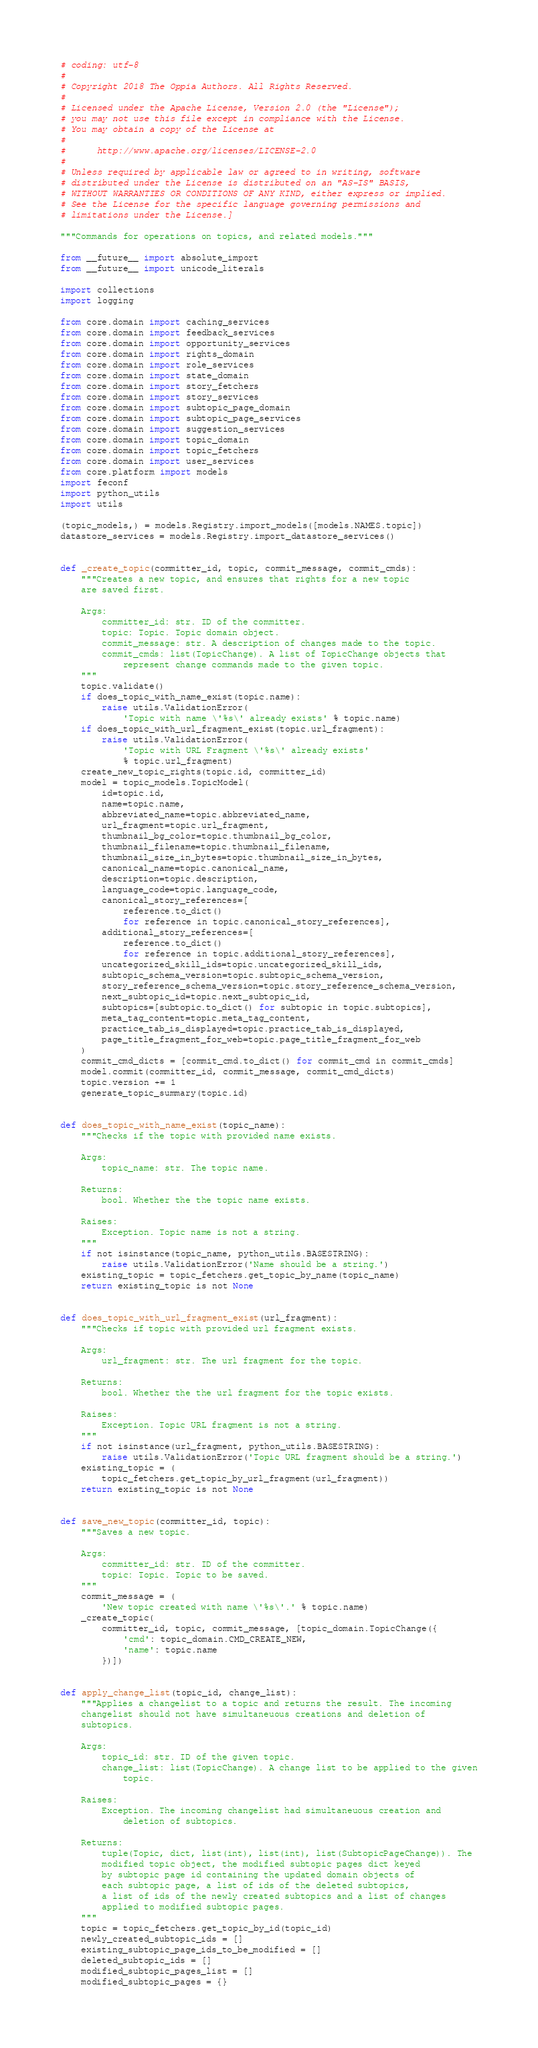<code> <loc_0><loc_0><loc_500><loc_500><_Python_># coding: utf-8
#
# Copyright 2018 The Oppia Authors. All Rights Reserved.
#
# Licensed under the Apache License, Version 2.0 (the "License");
# you may not use this file except in compliance with the License.
# You may obtain a copy of the License at
#
#      http://www.apache.org/licenses/LICENSE-2.0
#
# Unless required by applicable law or agreed to in writing, software
# distributed under the License is distributed on an "AS-IS" BASIS,
# WITHOUT WARRANTIES OR CONDITIONS OF ANY KIND, either express or implied.
# See the License for the specific language governing permissions and
# limitations under the License.]

"""Commands for operations on topics, and related models."""

from __future__ import absolute_import
from __future__ import unicode_literals

import collections
import logging

from core.domain import caching_services
from core.domain import feedback_services
from core.domain import opportunity_services
from core.domain import rights_domain
from core.domain import role_services
from core.domain import state_domain
from core.domain import story_fetchers
from core.domain import story_services
from core.domain import subtopic_page_domain
from core.domain import subtopic_page_services
from core.domain import suggestion_services
from core.domain import topic_domain
from core.domain import topic_fetchers
from core.domain import user_services
from core.platform import models
import feconf
import python_utils
import utils

(topic_models,) = models.Registry.import_models([models.NAMES.topic])
datastore_services = models.Registry.import_datastore_services()


def _create_topic(committer_id, topic, commit_message, commit_cmds):
    """Creates a new topic, and ensures that rights for a new topic
    are saved first.

    Args:
        committer_id: str. ID of the committer.
        topic: Topic. Topic domain object.
        commit_message: str. A description of changes made to the topic.
        commit_cmds: list(TopicChange). A list of TopicChange objects that
            represent change commands made to the given topic.
    """
    topic.validate()
    if does_topic_with_name_exist(topic.name):
        raise utils.ValidationError(
            'Topic with name \'%s\' already exists' % topic.name)
    if does_topic_with_url_fragment_exist(topic.url_fragment):
        raise utils.ValidationError(
            'Topic with URL Fragment \'%s\' already exists'
            % topic.url_fragment)
    create_new_topic_rights(topic.id, committer_id)
    model = topic_models.TopicModel(
        id=topic.id,
        name=topic.name,
        abbreviated_name=topic.abbreviated_name,
        url_fragment=topic.url_fragment,
        thumbnail_bg_color=topic.thumbnail_bg_color,
        thumbnail_filename=topic.thumbnail_filename,
        thumbnail_size_in_bytes=topic.thumbnail_size_in_bytes,
        canonical_name=topic.canonical_name,
        description=topic.description,
        language_code=topic.language_code,
        canonical_story_references=[
            reference.to_dict()
            for reference in topic.canonical_story_references],
        additional_story_references=[
            reference.to_dict()
            for reference in topic.additional_story_references],
        uncategorized_skill_ids=topic.uncategorized_skill_ids,
        subtopic_schema_version=topic.subtopic_schema_version,
        story_reference_schema_version=topic.story_reference_schema_version,
        next_subtopic_id=topic.next_subtopic_id,
        subtopics=[subtopic.to_dict() for subtopic in topic.subtopics],
        meta_tag_content=topic.meta_tag_content,
        practice_tab_is_displayed=topic.practice_tab_is_displayed,
        page_title_fragment_for_web=topic.page_title_fragment_for_web
    )
    commit_cmd_dicts = [commit_cmd.to_dict() for commit_cmd in commit_cmds]
    model.commit(committer_id, commit_message, commit_cmd_dicts)
    topic.version += 1
    generate_topic_summary(topic.id)


def does_topic_with_name_exist(topic_name):
    """Checks if the topic with provided name exists.

    Args:
        topic_name: str. The topic name.

    Returns:
        bool. Whether the the topic name exists.

    Raises:
        Exception. Topic name is not a string.
    """
    if not isinstance(topic_name, python_utils.BASESTRING):
        raise utils.ValidationError('Name should be a string.')
    existing_topic = topic_fetchers.get_topic_by_name(topic_name)
    return existing_topic is not None


def does_topic_with_url_fragment_exist(url_fragment):
    """Checks if topic with provided url fragment exists.

    Args:
        url_fragment: str. The url fragment for the topic.

    Returns:
        bool. Whether the the url fragment for the topic exists.

    Raises:
        Exception. Topic URL fragment is not a string.
    """
    if not isinstance(url_fragment, python_utils.BASESTRING):
        raise utils.ValidationError('Topic URL fragment should be a string.')
    existing_topic = (
        topic_fetchers.get_topic_by_url_fragment(url_fragment))
    return existing_topic is not None


def save_new_topic(committer_id, topic):
    """Saves a new topic.

    Args:
        committer_id: str. ID of the committer.
        topic: Topic. Topic to be saved.
    """
    commit_message = (
        'New topic created with name \'%s\'.' % topic.name)
    _create_topic(
        committer_id, topic, commit_message, [topic_domain.TopicChange({
            'cmd': topic_domain.CMD_CREATE_NEW,
            'name': topic.name
        })])


def apply_change_list(topic_id, change_list):
    """Applies a changelist to a topic and returns the result. The incoming
    changelist should not have simultaneuous creations and deletion of
    subtopics.

    Args:
        topic_id: str. ID of the given topic.
        change_list: list(TopicChange). A change list to be applied to the given
            topic.

    Raises:
        Exception. The incoming changelist had simultaneuous creation and
            deletion of subtopics.

    Returns:
        tuple(Topic, dict, list(int), list(int), list(SubtopicPageChange)). The
        modified topic object, the modified subtopic pages dict keyed
        by subtopic page id containing the updated domain objects of
        each subtopic page, a list of ids of the deleted subtopics,
        a list of ids of the newly created subtopics and a list of changes
        applied to modified subtopic pages.
    """
    topic = topic_fetchers.get_topic_by_id(topic_id)
    newly_created_subtopic_ids = []
    existing_subtopic_page_ids_to_be_modified = []
    deleted_subtopic_ids = []
    modified_subtopic_pages_list = []
    modified_subtopic_pages = {}</code> 